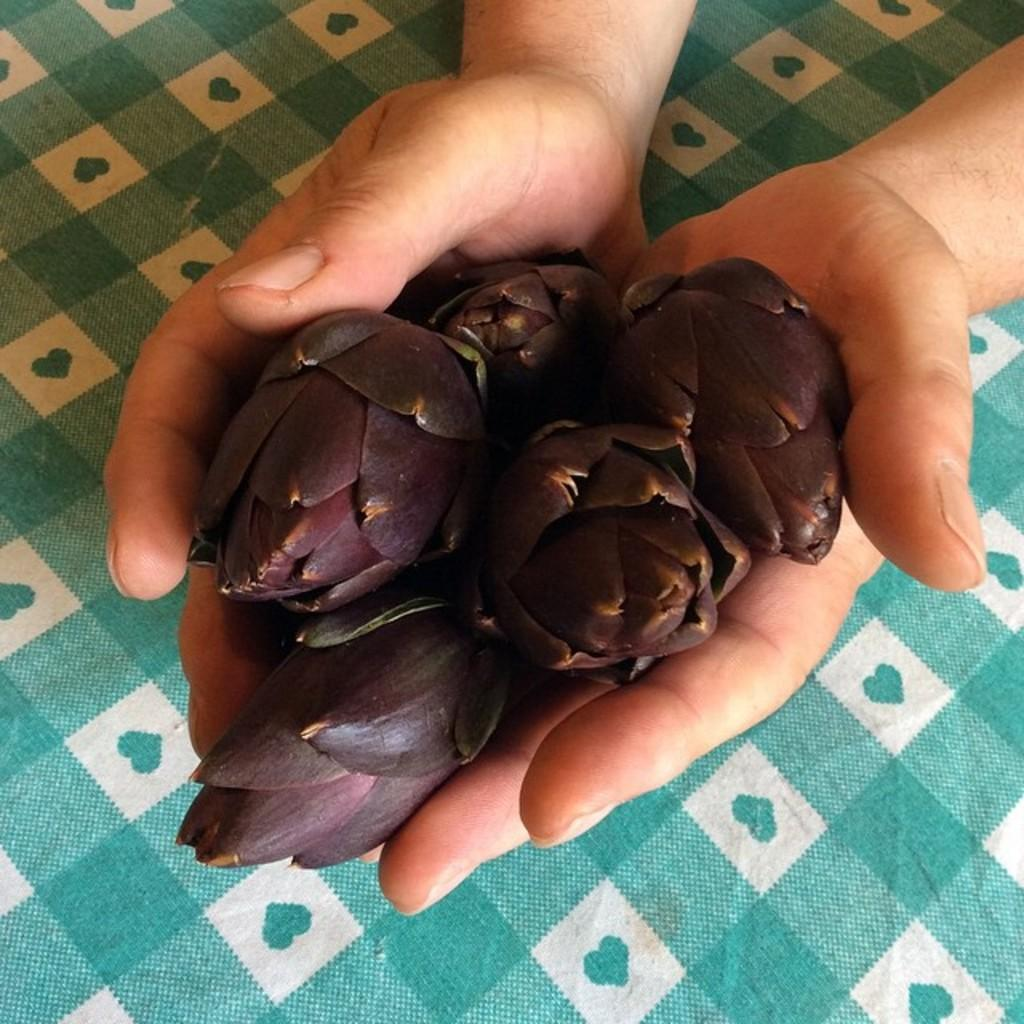What is being held in the person's hand in the image? There is a person's hand holding flowers in the image. What can be said about the color of the flowers? The flowers are brown in color. What can be seen in the background of the image? There is a cloth in the background of the image. What colors are present on the cloth? The cloth has green and white colors. Is the pipe in the image being used to water the flowers? There is no pipe present in the image, so it cannot be used to water the flowers. 